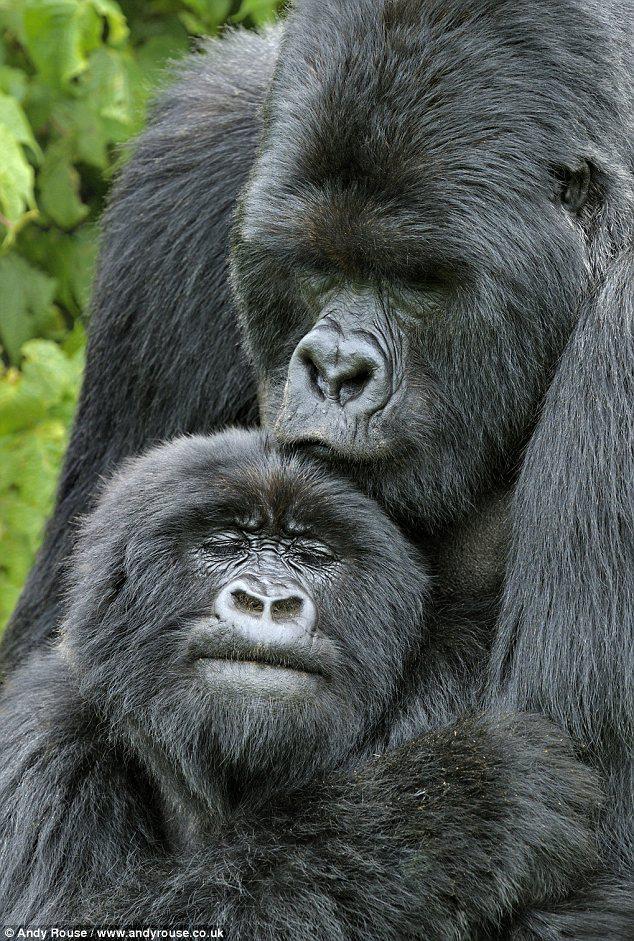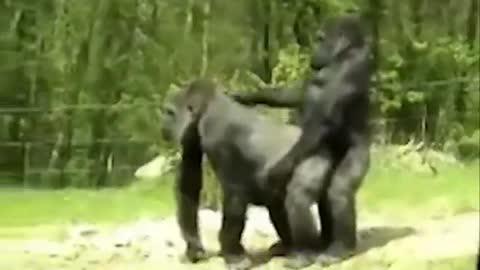The first image is the image on the left, the second image is the image on the right. For the images shown, is this caption "There is a single male ape not looking at the camera." true? Answer yes or no. No. 